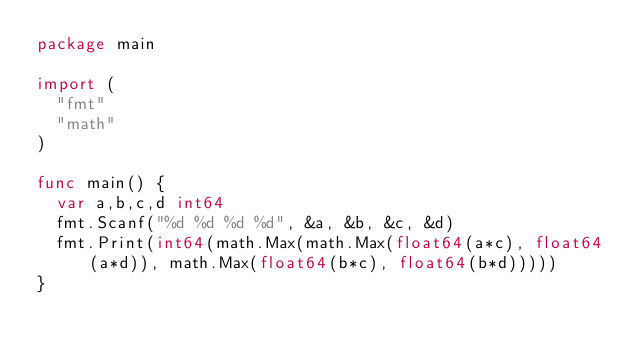<code> <loc_0><loc_0><loc_500><loc_500><_Go_>package main

import (
	"fmt"
	"math"
)

func main() {
	var a,b,c,d int64
	fmt.Scanf("%d %d %d %d", &a, &b, &c, &d)
	fmt.Print(int64(math.Max(math.Max(float64(a*c), float64(a*d)), math.Max(float64(b*c), float64(b*d)))))
}
</code> 